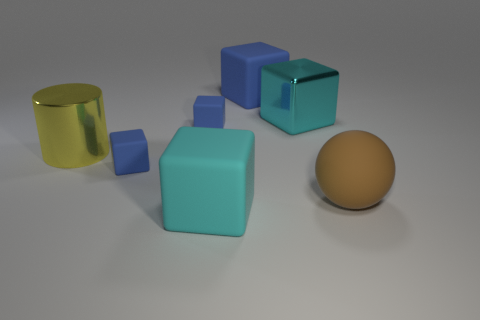How many other objects are the same material as the large brown object? 4 